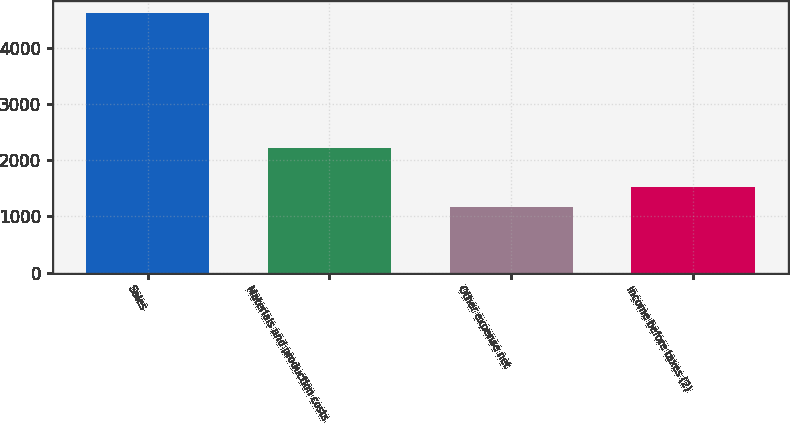<chart> <loc_0><loc_0><loc_500><loc_500><bar_chart><fcel>Sales<fcel>Materials and production costs<fcel>Other expense net<fcel>Income before taxes (2)<nl><fcel>4611<fcel>2222<fcel>1175<fcel>1518.6<nl></chart> 